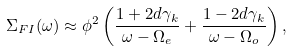<formula> <loc_0><loc_0><loc_500><loc_500>\Sigma _ { F I } ( \omega ) \approx \phi ^ { 2 } \left ( \frac { 1 + 2 d \gamma _ { k } } { \omega - \Omega _ { e } } + \frac { 1 - 2 d \gamma _ { k } } { \omega - \Omega _ { o } } \right ) ,</formula> 